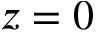<formula> <loc_0><loc_0><loc_500><loc_500>z = 0</formula> 